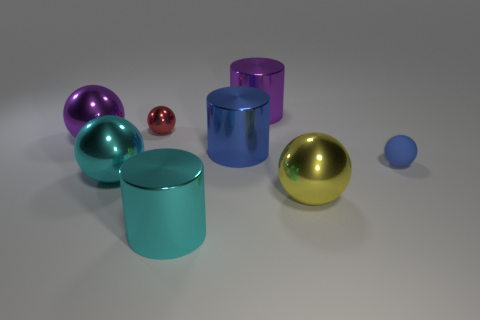Are there any other things that are made of the same material as the tiny blue ball?
Your response must be concise. No. There is a sphere that is behind the large purple shiny thing in front of the purple cylinder; how many matte spheres are in front of it?
Offer a very short reply. 1. Is the blue rubber object the same shape as the big yellow metal object?
Your answer should be compact. Yes. Is there another blue rubber object of the same shape as the small blue object?
Offer a terse response. No. The blue metallic thing that is the same size as the purple cylinder is what shape?
Provide a succinct answer. Cylinder. What material is the large thing that is to the right of the big thing behind the large shiny ball that is behind the blue rubber object made of?
Your answer should be very brief. Metal. Is the blue shiny object the same size as the yellow metal sphere?
Give a very brief answer. Yes. What material is the big blue cylinder?
Offer a very short reply. Metal. Is the shape of the tiny blue object that is right of the red sphere the same as  the blue metal thing?
Your answer should be compact. No. How many objects are either tiny blue spheres or blue metallic cylinders?
Your response must be concise. 2. 